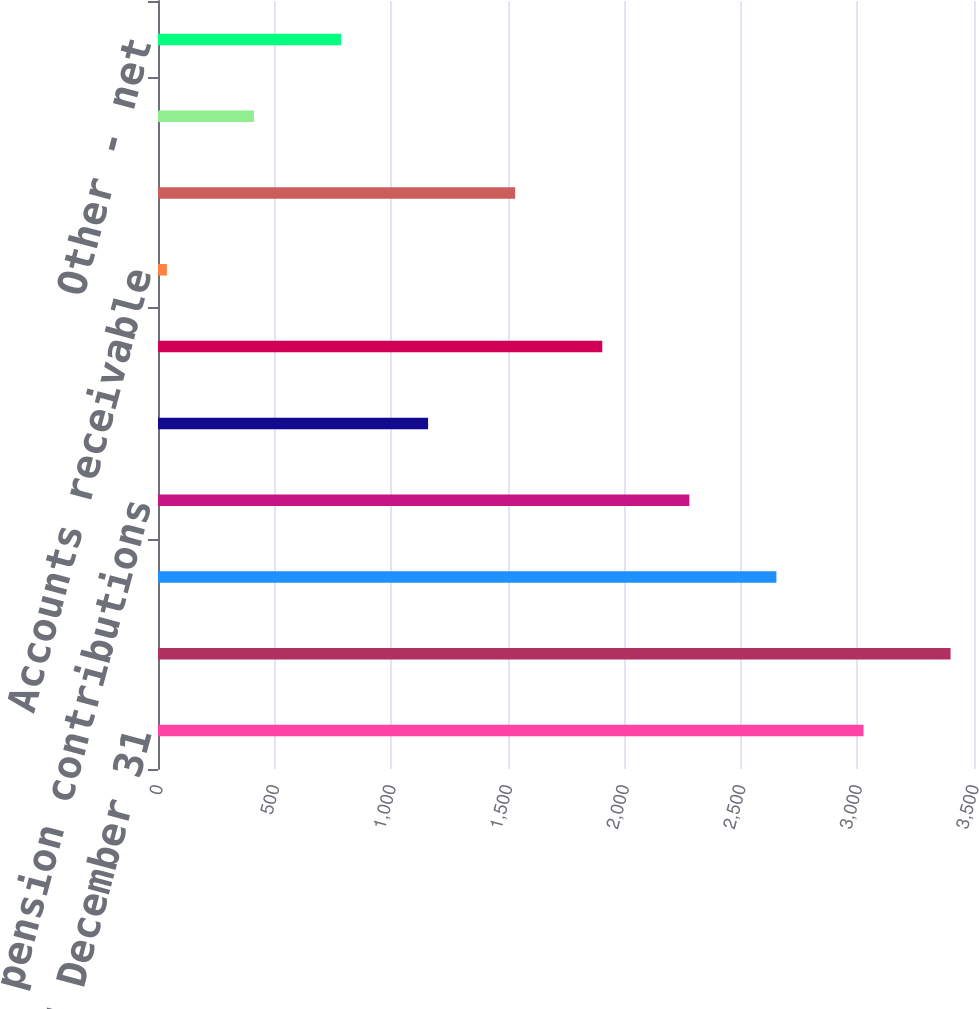Convert chart. <chart><loc_0><loc_0><loc_500><loc_500><bar_chart><fcel>Years ended December 31<fcel>Net income<fcel>Depreciation and amortization<fcel>Company pension contributions<fcel>Company pension expense<fcel>Income taxes (deferred and<fcel>Accounts receivable<fcel>Inventories<fcel>Accounts payable<fcel>Other - net<nl><fcel>3026<fcel>3399.5<fcel>2652.5<fcel>2279<fcel>1158.5<fcel>1905.5<fcel>38<fcel>1532<fcel>411.5<fcel>785<nl></chart> 